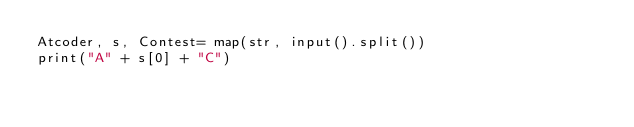<code> <loc_0><loc_0><loc_500><loc_500><_Python_>Atcoder, s, Contest= map(str, input().split())
print("A" + s[0] + "C")</code> 